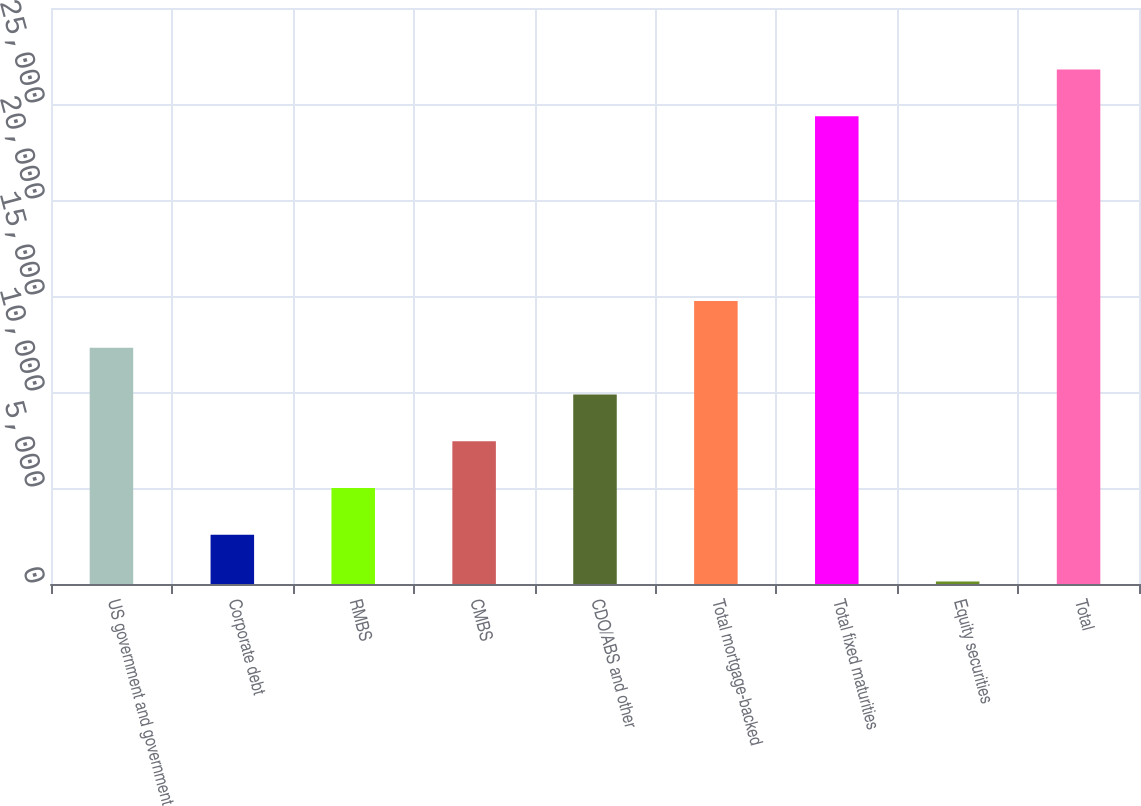Convert chart. <chart><loc_0><loc_0><loc_500><loc_500><bar_chart><fcel>US government and government<fcel>Corporate debt<fcel>RMBS<fcel>CMBS<fcel>CDO/ABS and other<fcel>Total mortgage-backed<fcel>Total fixed maturities<fcel>Equity securities<fcel>Total<nl><fcel>12307<fcel>2561.4<fcel>4997.8<fcel>7434.2<fcel>9870.6<fcel>14743.4<fcel>24364<fcel>125<fcel>26800.4<nl></chart> 